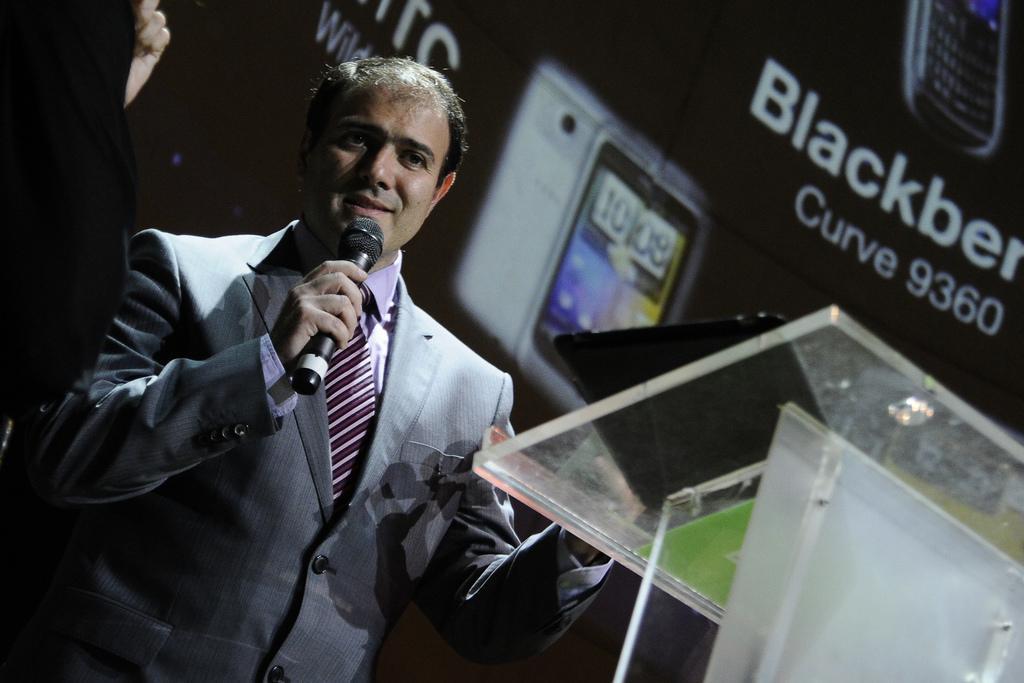Please provide a concise description of this image. Here we can see a man who is talking on the mike. He is in a suit. This is table. On the background there is a banner and this is mobile. 